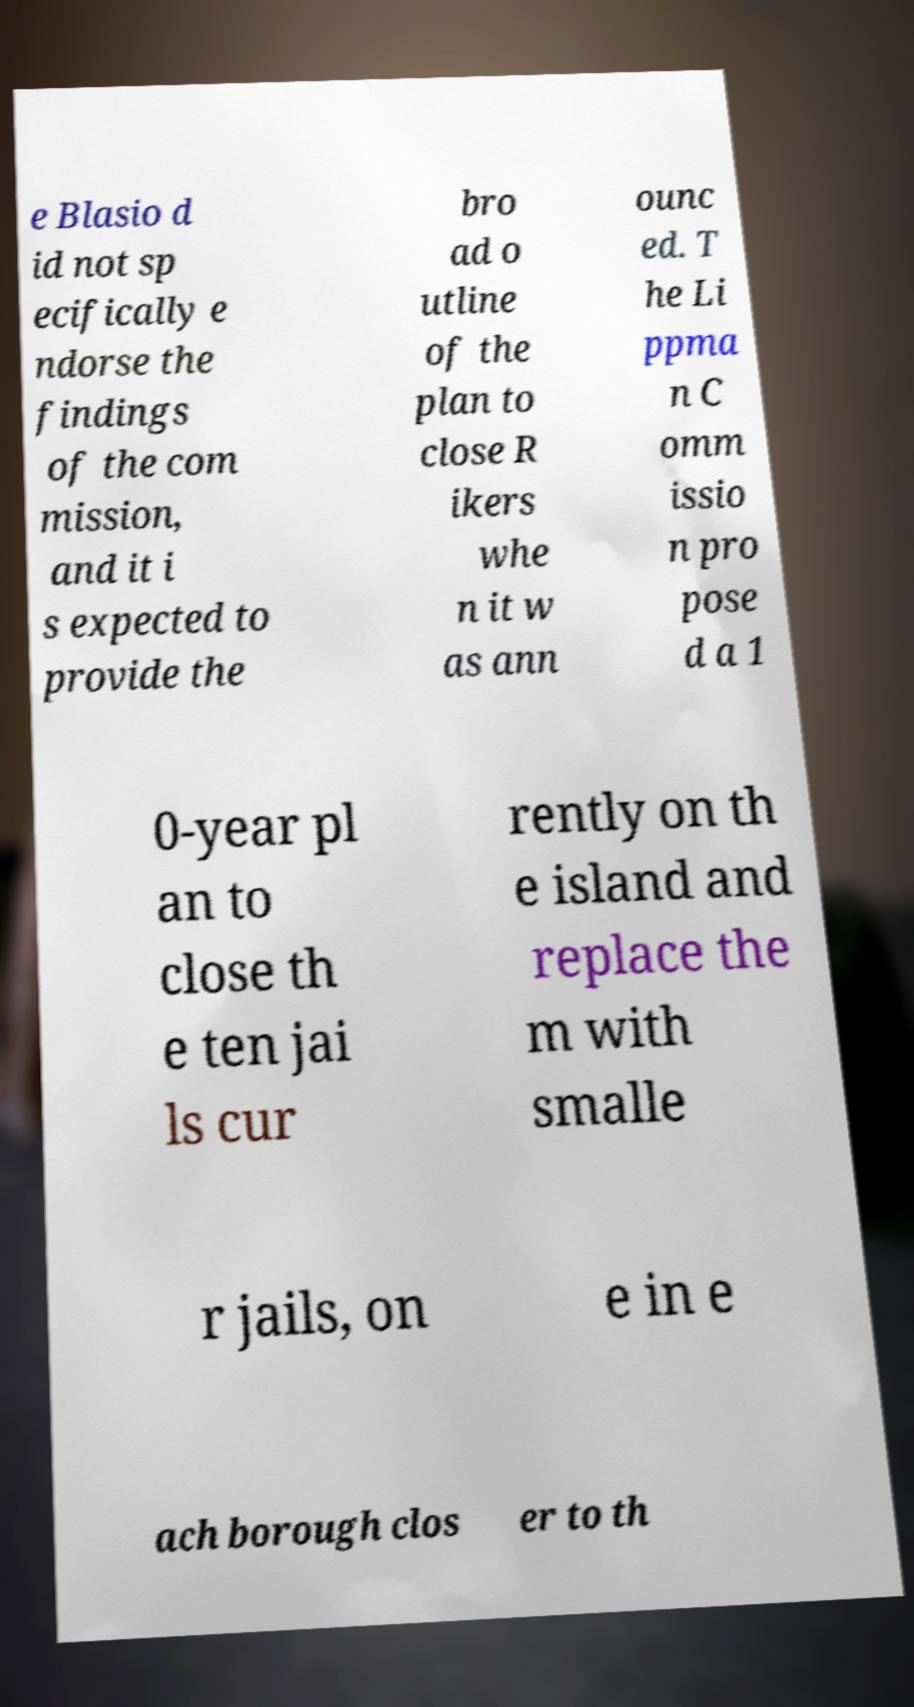Can you accurately transcribe the text from the provided image for me? e Blasio d id not sp ecifically e ndorse the findings of the com mission, and it i s expected to provide the bro ad o utline of the plan to close R ikers whe n it w as ann ounc ed. T he Li ppma n C omm issio n pro pose d a 1 0-year pl an to close th e ten jai ls cur rently on th e island and replace the m with smalle r jails, on e in e ach borough clos er to th 